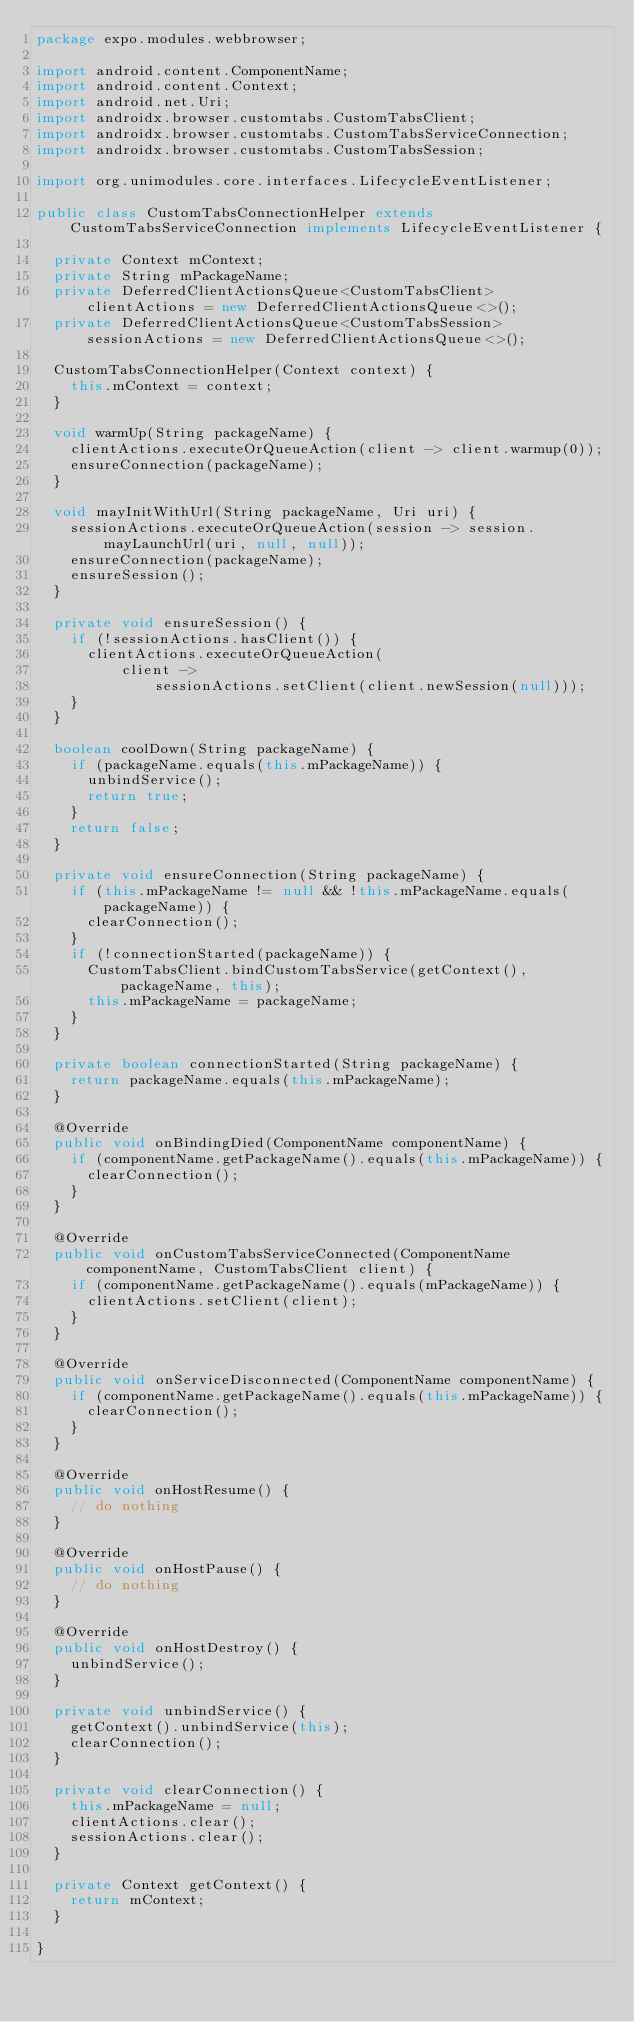Convert code to text. <code><loc_0><loc_0><loc_500><loc_500><_Java_>package expo.modules.webbrowser;

import android.content.ComponentName;
import android.content.Context;
import android.net.Uri;
import androidx.browser.customtabs.CustomTabsClient;
import androidx.browser.customtabs.CustomTabsServiceConnection;
import androidx.browser.customtabs.CustomTabsSession;

import org.unimodules.core.interfaces.LifecycleEventListener;

public class CustomTabsConnectionHelper extends CustomTabsServiceConnection implements LifecycleEventListener {

  private Context mContext;
  private String mPackageName;
  private DeferredClientActionsQueue<CustomTabsClient> clientActions = new DeferredClientActionsQueue<>();
  private DeferredClientActionsQueue<CustomTabsSession> sessionActions = new DeferredClientActionsQueue<>();

  CustomTabsConnectionHelper(Context context) {
    this.mContext = context;
  }

  void warmUp(String packageName) {
    clientActions.executeOrQueueAction(client -> client.warmup(0));
    ensureConnection(packageName);
  }

  void mayInitWithUrl(String packageName, Uri uri) {
    sessionActions.executeOrQueueAction(session -> session.mayLaunchUrl(uri, null, null));
    ensureConnection(packageName);
    ensureSession();
  }

  private void ensureSession() {
    if (!sessionActions.hasClient()) {
      clientActions.executeOrQueueAction(
          client ->
              sessionActions.setClient(client.newSession(null)));
    }
  }

  boolean coolDown(String packageName) {
    if (packageName.equals(this.mPackageName)) {
      unbindService();
      return true;
    }
    return false;
  }

  private void ensureConnection(String packageName) {
    if (this.mPackageName != null && !this.mPackageName.equals(packageName)) {
      clearConnection();
    }
    if (!connectionStarted(packageName)) {
      CustomTabsClient.bindCustomTabsService(getContext(), packageName, this);
      this.mPackageName = packageName;
    }
  }

  private boolean connectionStarted(String packageName) {
    return packageName.equals(this.mPackageName);
  }

  @Override
  public void onBindingDied(ComponentName componentName) {
    if (componentName.getPackageName().equals(this.mPackageName)) {
      clearConnection();
    }
  }

  @Override
  public void onCustomTabsServiceConnected(ComponentName componentName, CustomTabsClient client) {
    if (componentName.getPackageName().equals(mPackageName)) {
      clientActions.setClient(client);
    }
  }

  @Override
  public void onServiceDisconnected(ComponentName componentName) {
    if (componentName.getPackageName().equals(this.mPackageName)) {
      clearConnection();
    }
  }

  @Override
  public void onHostResume() {
    // do nothing
  }

  @Override
  public void onHostPause() {
    // do nothing
  }

  @Override
  public void onHostDestroy() {
    unbindService();
  }

  private void unbindService() {
    getContext().unbindService(this);
    clearConnection();
  }

  private void clearConnection() {
    this.mPackageName = null;
    clientActions.clear();
    sessionActions.clear();
  }

  private Context getContext() {
    return mContext;
  }

}
</code> 